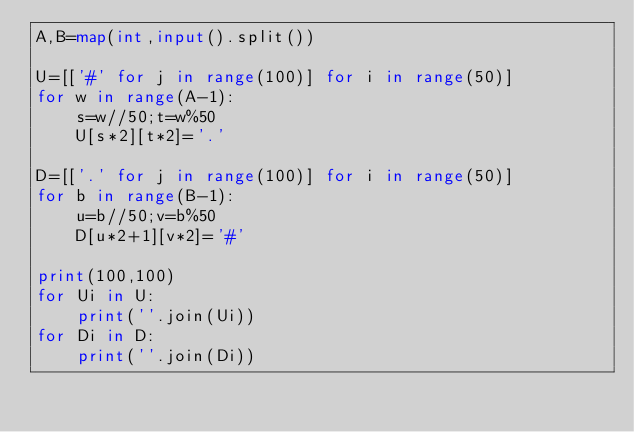Convert code to text. <code><loc_0><loc_0><loc_500><loc_500><_Python_>A,B=map(int,input().split())

U=[['#' for j in range(100)] for i in range(50)]
for w in range(A-1):
    s=w//50;t=w%50
    U[s*2][t*2]='.'

D=[['.' for j in range(100)] for i in range(50)]
for b in range(B-1):
    u=b//50;v=b%50
    D[u*2+1][v*2]='#'

print(100,100)
for Ui in U:
    print(''.join(Ui))
for Di in D:
    print(''.join(Di))</code> 